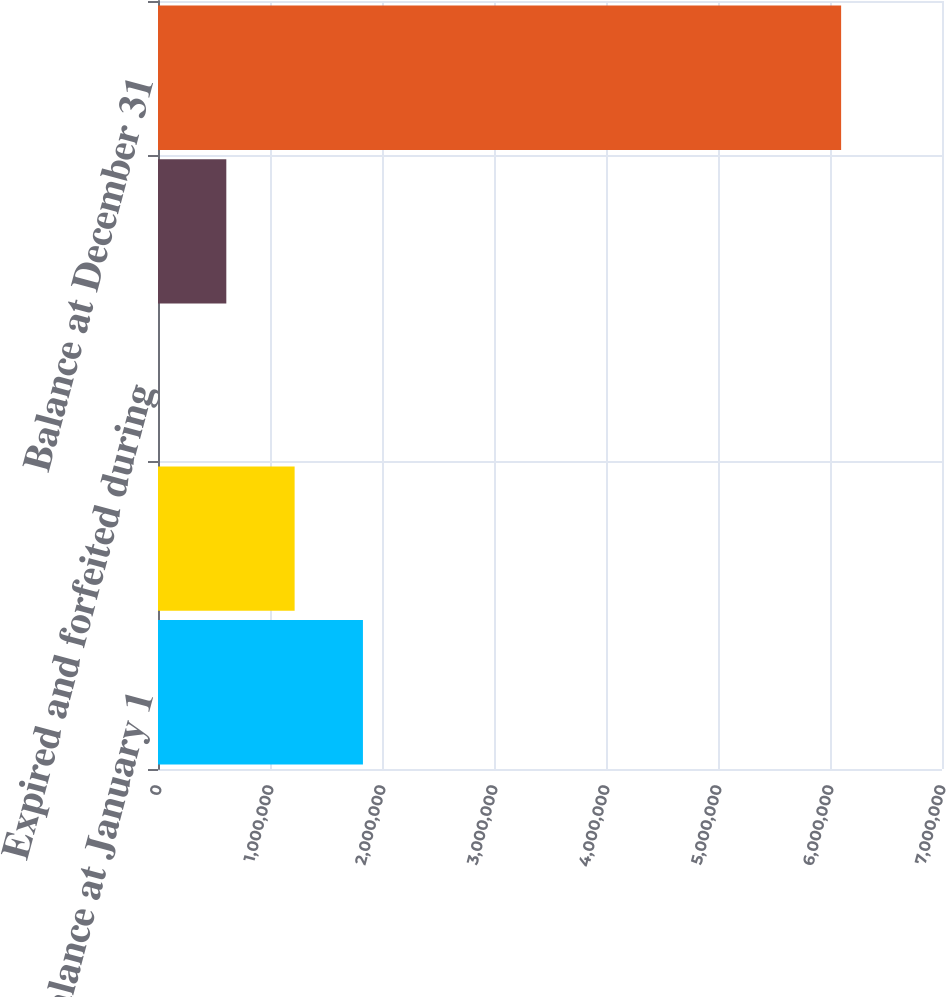<chart> <loc_0><loc_0><loc_500><loc_500><bar_chart><fcel>Balance at January 1<fcel>Cancellation of available<fcel>Expired and forfeited during<fcel>Restricted stock and<fcel>Balance at December 31<nl><fcel>1.8298e+06<fcel>1.21987e+06<fcel>1.77<fcel>609936<fcel>6.09934e+06<nl></chart> 